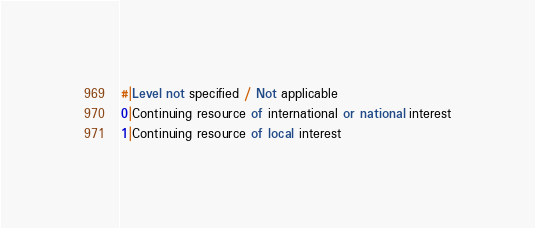<code> <loc_0><loc_0><loc_500><loc_500><_SQL_>#|Level not specified / Not applicable
0|Continuing resource of international or national interest
1|Continuing resource of local interest</code> 